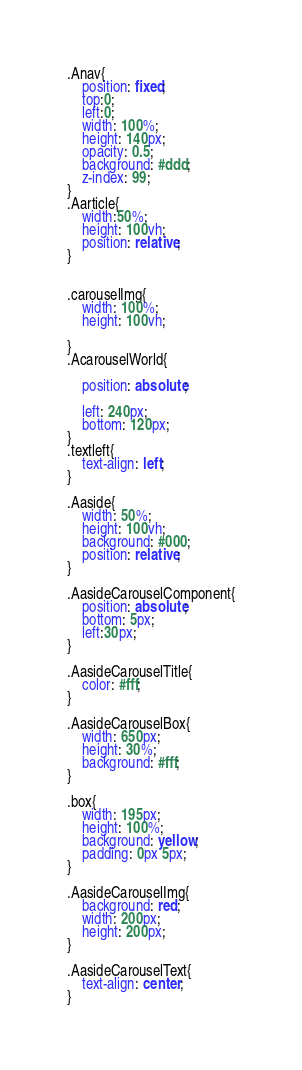<code> <loc_0><loc_0><loc_500><loc_500><_CSS_>.Anav{
    position: fixed;
    top:0;
    left:0;
    width: 100%;
    height: 140px;
    opacity: 0.5;
    background: #ddd;
    z-index: 99;
}
.Aarticle{
    width:50%;
    height: 100vh;
    position: relative;
}


.carouselImg{
    width: 100%;
    height: 100vh;
   
}
.AcarouselWorld{
   
    position: absolute;

    left: 240px;
    bottom: 120px;
}
.textleft{
    text-align: left;
}

.Aaside{
    width: 50%;
    height: 100vh;
    background: #000;
    position: relative;
}

.AasideCarouselComponent{
    position: absolute;
    bottom: 5px;
    left:30px;
}

.AasideCarouselTitle{
    color: #fff;
}

.AasideCarouselBox{
    width: 650px;
    height: 30%;
    background: #fff;
}

.box{
    width: 195px;
    height: 100%;
    background: yellow;
    padding: 0px 5px;
}

.AasideCarouselImg{
    background: red;
    width: 200px;
    height: 200px;
}

.AasideCarouselText{
    text-align: center;
}

</code> 